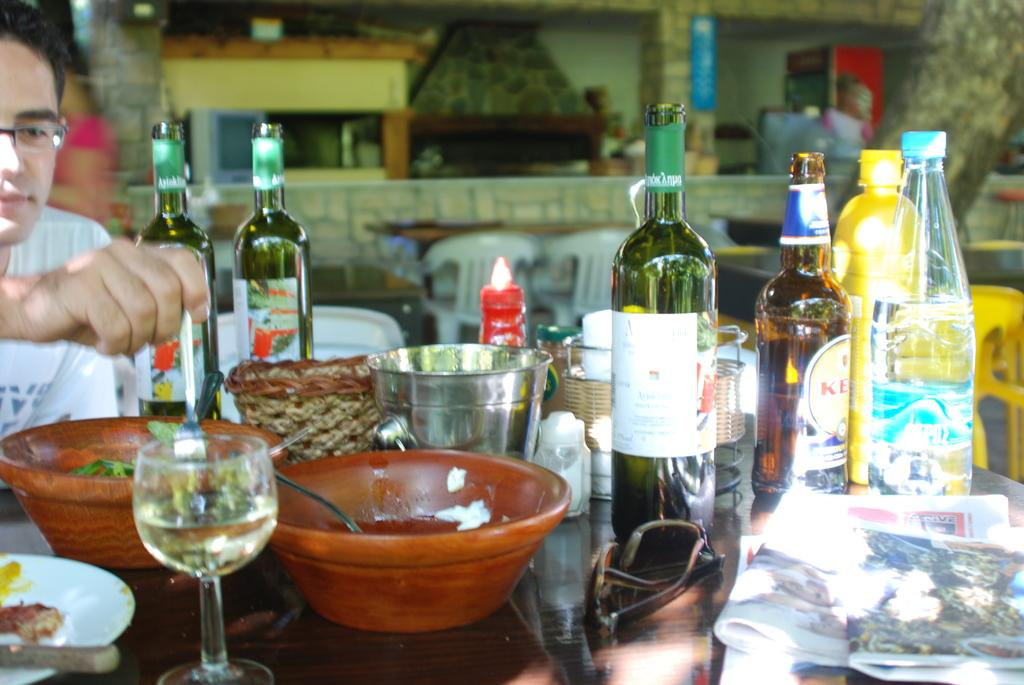What objects can be seen in the image related to serving or consuming liquids? There are bottles and glasses in the image. What other items are present on the table in the image? There are bowls on the table in the image. What is the man in the image doing? The man is seated in the image and holding a phone in his hand. How many crows are perched on the man's shoulder in the image? There are no crows present in the image. What type of giants can be seen interacting with the man in the image? There are no giants present in the image. 